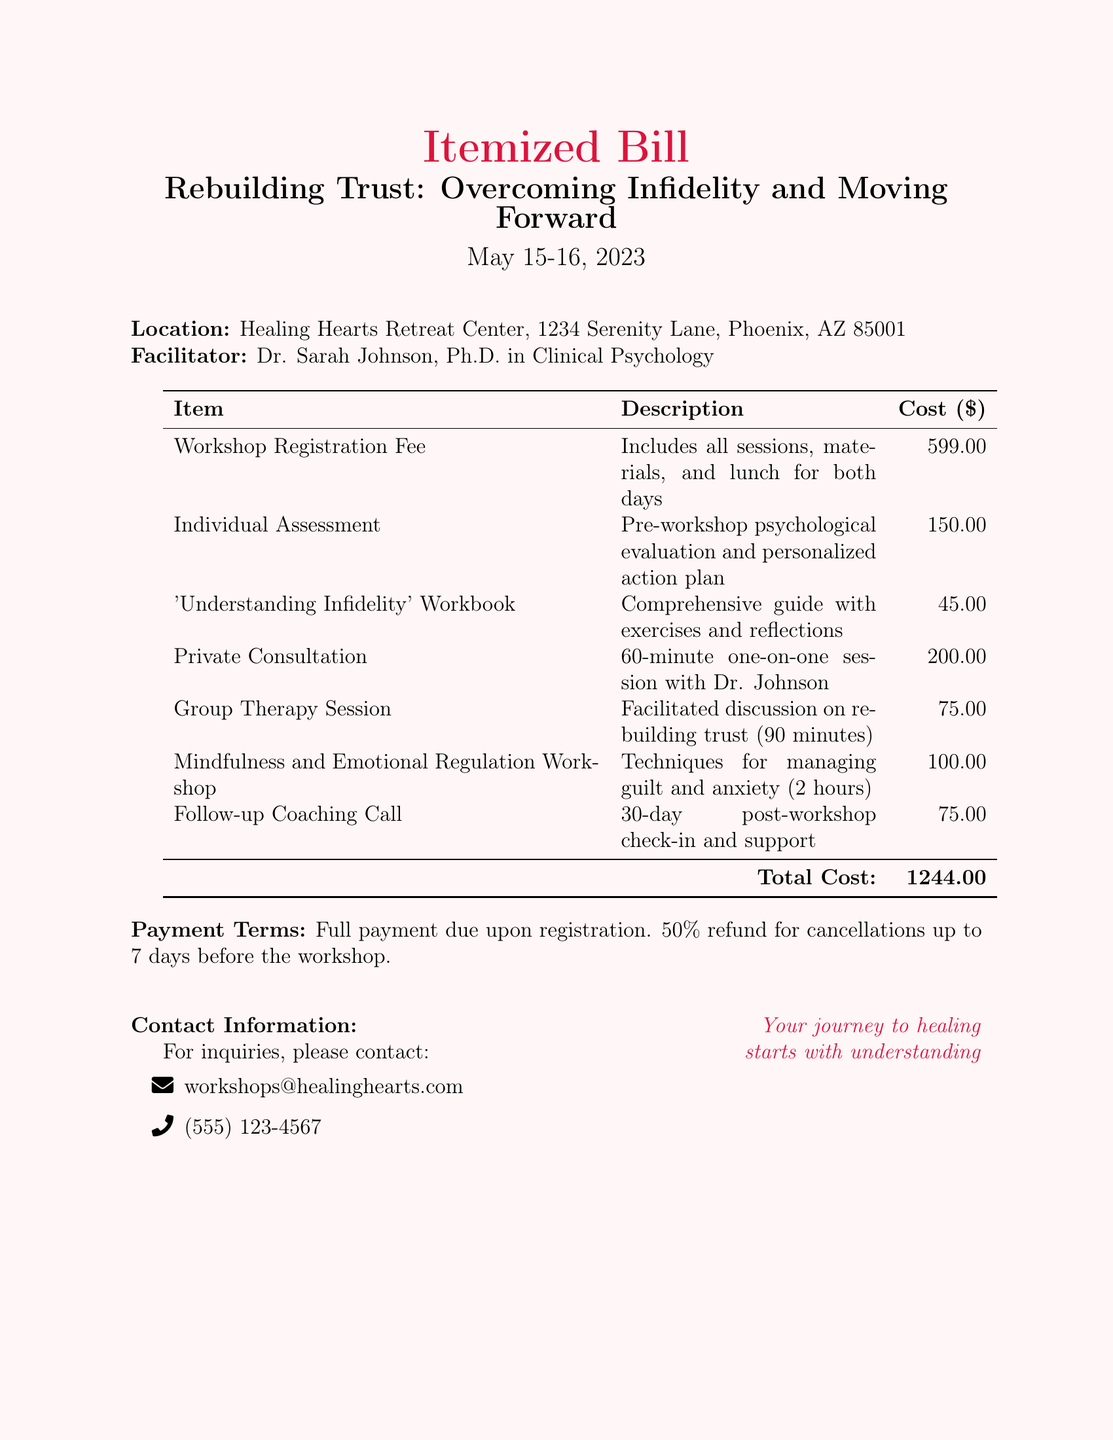What is the location of the workshop? The location of the workshop is specified in the document and is Healing Hearts Retreat Center, 1234 Serenity Lane, Phoenix, AZ 85001.
Answer: Healing Hearts Retreat Center, 1234 Serenity Lane, Phoenix, AZ 85001 Who is the facilitator of the workshop? The document identifies Dr. Sarah Johnson as the facilitator and provides her credentials.
Answer: Dr. Sarah Johnson What is the date of the workshop? The document includes specific dates for the workshop, which are indicated clearly.
Answer: May 15-16, 2023 How much does the workshop registration fee cost? The registration fee is listed in the itemized bill under the workshop registration fee section.
Answer: 599.00 What is included in the Individual Assessment? The document provides a description of what the Individual Assessment entails, specifically mentioning a pre-workshop evaluation and action plan.
Answer: Pre-workshop psychological evaluation and personalized action plan How long is the Private Consultation session? The duration of the Private Consultation is explicitly stated in the itemized description.
Answer: 60-minute What is the total cost of the workshop? The total cost is calculated from the items listed and is provided at the bottom of the bill.
Answer: 1244.00 What is the refund policy for cancellations? The document outlines the cancellation policy, including the terms for receiving a refund.
Answer: 50% refund for cancellations up to 7 days before the workshop What additional support is offered after the workshop? The itemized bill mentions follow-up support, which is illustrated in a specific session listed.
Answer: Follow-up Coaching Call What type of workshop is being offered? The title and focus of the workshop are provided in the heading of the document.
Answer: Rebuilding Trust: Overcoming Infidelity and Moving Forward 